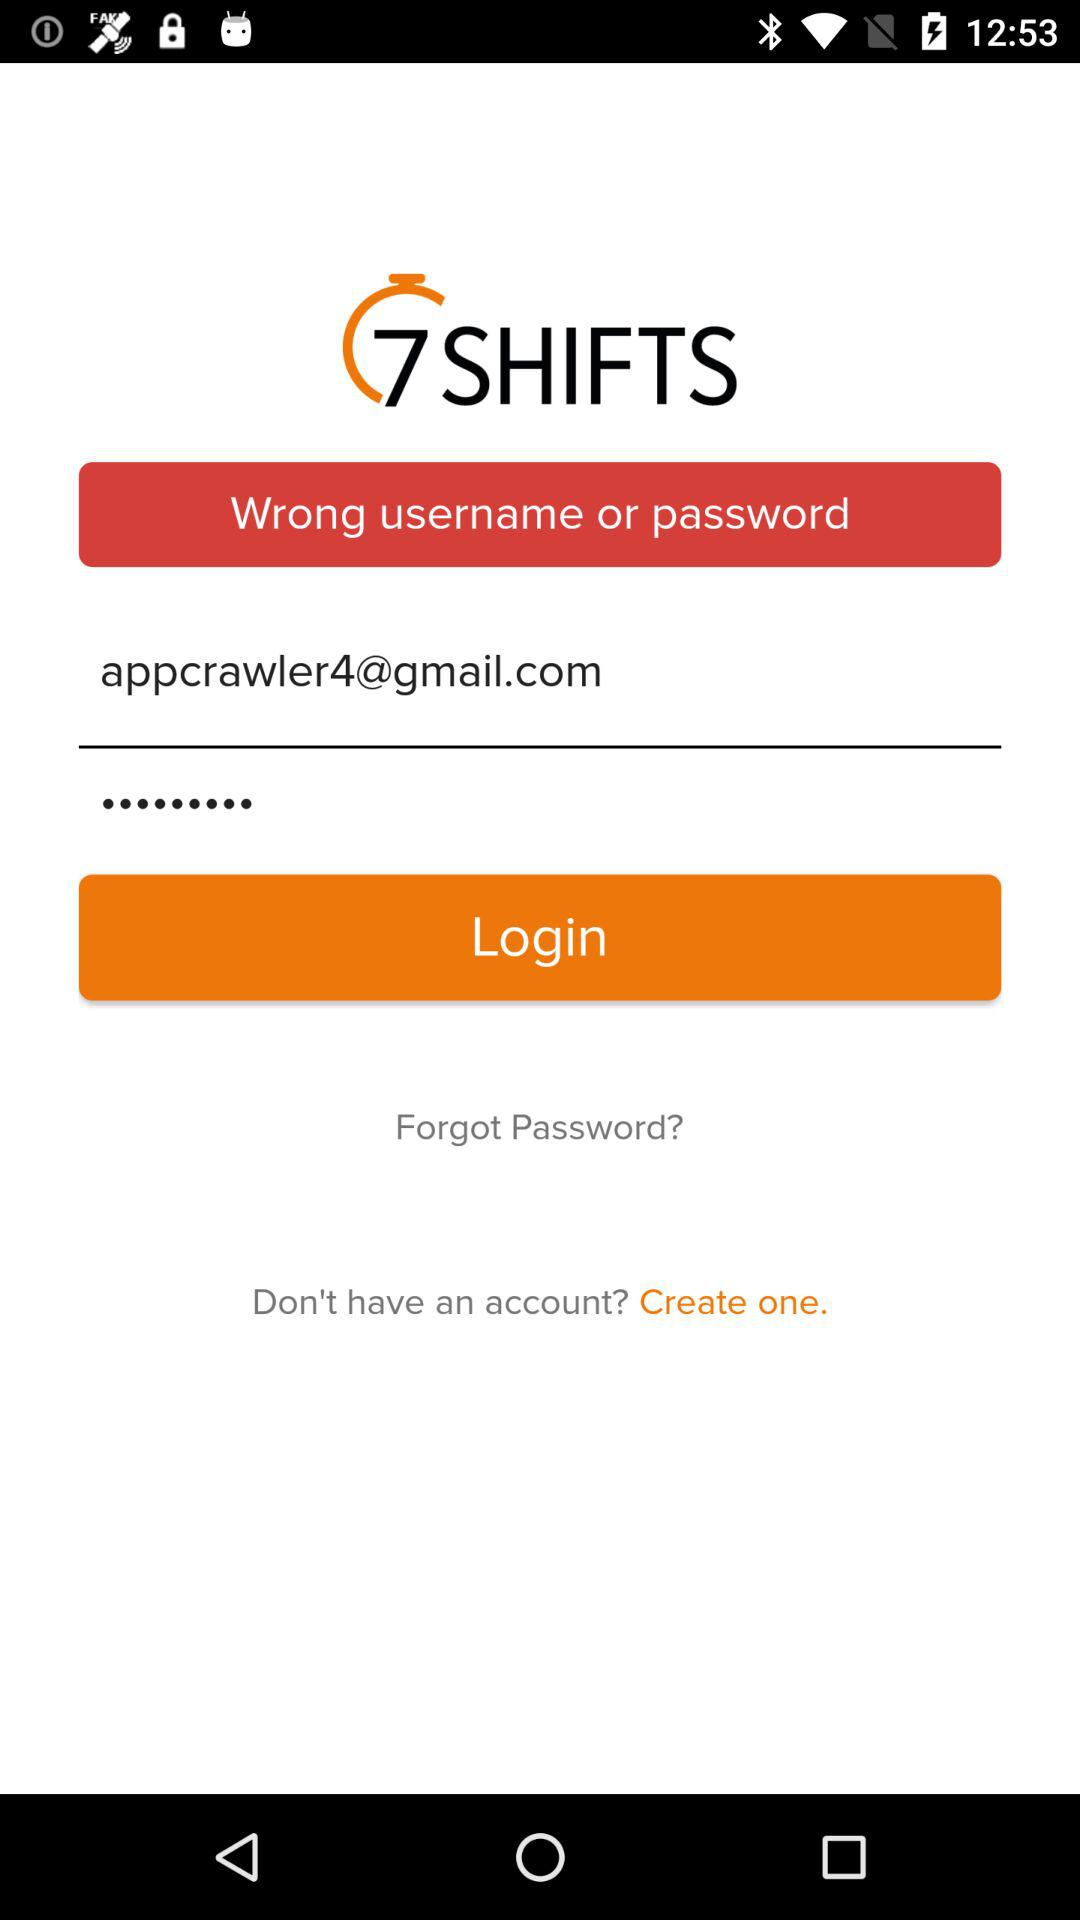What is the given email address? The given email address is appcrawler4@gmail.com. 